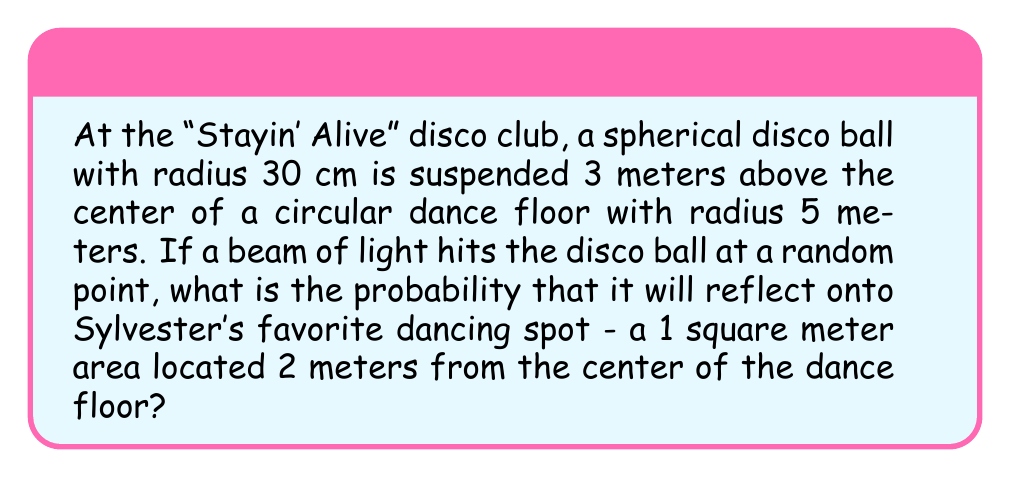Teach me how to tackle this problem. Let's approach this step-by-step:

1) First, we need to understand that this is a problem of geometric probability. The probability will be the ratio of the favorable area to the total area.

2) The total area is the surface area of the disco ball, as the light can hit anywhere on its surface:
   $$A_{total} = 4\pi r^2 = 4\pi (0.3)^2 \approx 1.13 \text{ m}^2$$

3) The favorable area is the portion of the disco ball's surface that would reflect light onto Sylvester's spot. To find this, we need to determine the solid angle subtended by Sylvester's spot at the disco ball.

4) The solid angle ($\Omega$) is given by:
   $$\Omega = \frac{A \cos(\theta)}{d^2}$$
   where $A$ is the area of Sylvester's spot, $d$ is the distance from the disco ball to the spot, and $\theta$ is the angle between the normal to the surface and the line to the disco ball.

5) We can find $d$ using the Pythagorean theorem:
   $$d = \sqrt{3^2 + 2^2} = \sqrt{13} \approx 3.61 \text{ m}$$

6) The angle $\theta$ can be found using:
   $$\cos(\theta) = \frac{3}{3.61} \approx 0.831$$

7) Now we can calculate the solid angle:
   $$\Omega = \frac{1 \cdot 0.831}{3.61^2} \approx 0.0638 \text{ steradians}$$

8) The favorable area on the disco ball is this solid angle multiplied by the square of the ball's radius:
   $$A_{favorable} = 0.0638 \cdot 0.3^2 \approx 0.00574 \text{ m}^2$$

9) The probability is then:
   $$P = \frac{A_{favorable}}{A_{total}} = \frac{0.00574}{1.13} \approx 0.00508$$
Answer: $0.00508$ or $0.508\%$ 